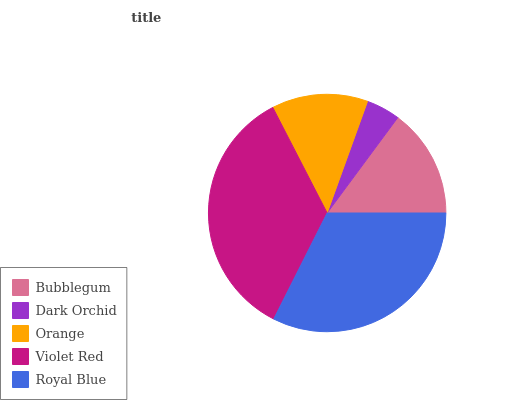Is Dark Orchid the minimum?
Answer yes or no. Yes. Is Violet Red the maximum?
Answer yes or no. Yes. Is Orange the minimum?
Answer yes or no. No. Is Orange the maximum?
Answer yes or no. No. Is Orange greater than Dark Orchid?
Answer yes or no. Yes. Is Dark Orchid less than Orange?
Answer yes or no. Yes. Is Dark Orchid greater than Orange?
Answer yes or no. No. Is Orange less than Dark Orchid?
Answer yes or no. No. Is Bubblegum the high median?
Answer yes or no. Yes. Is Bubblegum the low median?
Answer yes or no. Yes. Is Dark Orchid the high median?
Answer yes or no. No. Is Orange the low median?
Answer yes or no. No. 